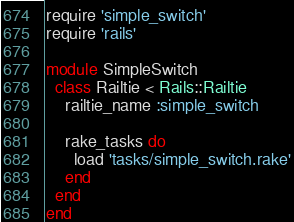<code> <loc_0><loc_0><loc_500><loc_500><_Ruby_>require 'simple_switch'
require 'rails'

module SimpleSwitch
  class Railtie < Rails::Railtie
    railtie_name :simple_switch

    rake_tasks do
      load 'tasks/simple_switch.rake'
    end
  end
end</code> 